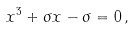<formula> <loc_0><loc_0><loc_500><loc_500>x ^ { 3 } + \sigma x - \sigma = 0 \, ,</formula> 